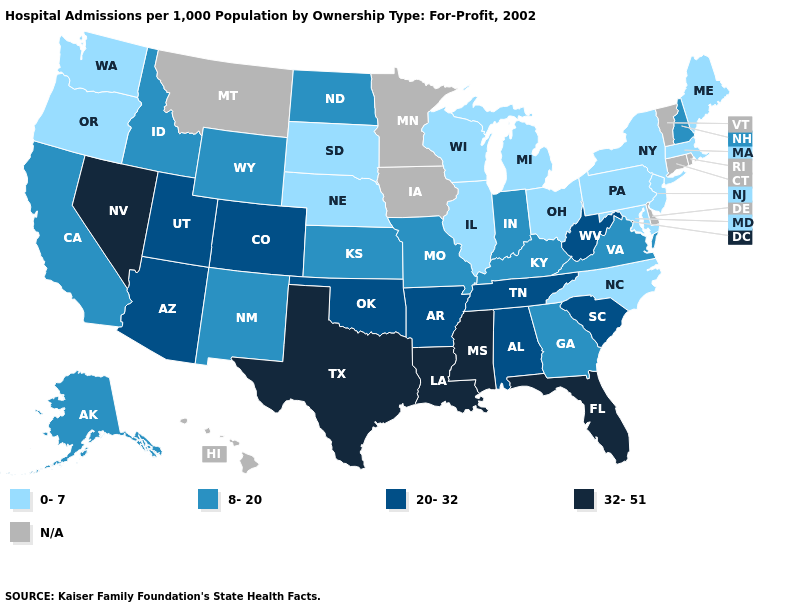Does Mississippi have the highest value in the South?
Be succinct. Yes. Does Oregon have the lowest value in the West?
Give a very brief answer. Yes. What is the lowest value in states that border Montana?
Write a very short answer. 0-7. What is the value of Minnesota?
Keep it brief. N/A. What is the value of Idaho?
Answer briefly. 8-20. What is the value of South Dakota?
Be succinct. 0-7. What is the lowest value in the USA?
Concise answer only. 0-7. What is the value of New Mexico?
Give a very brief answer. 8-20. What is the lowest value in the Northeast?
Short answer required. 0-7. What is the lowest value in the MidWest?
Keep it brief. 0-7. Name the states that have a value in the range 8-20?
Answer briefly. Alaska, California, Georgia, Idaho, Indiana, Kansas, Kentucky, Missouri, New Hampshire, New Mexico, North Dakota, Virginia, Wyoming. Does the map have missing data?
Short answer required. Yes. How many symbols are there in the legend?
Short answer required. 5. Name the states that have a value in the range 20-32?
Be succinct. Alabama, Arizona, Arkansas, Colorado, Oklahoma, South Carolina, Tennessee, Utah, West Virginia. 